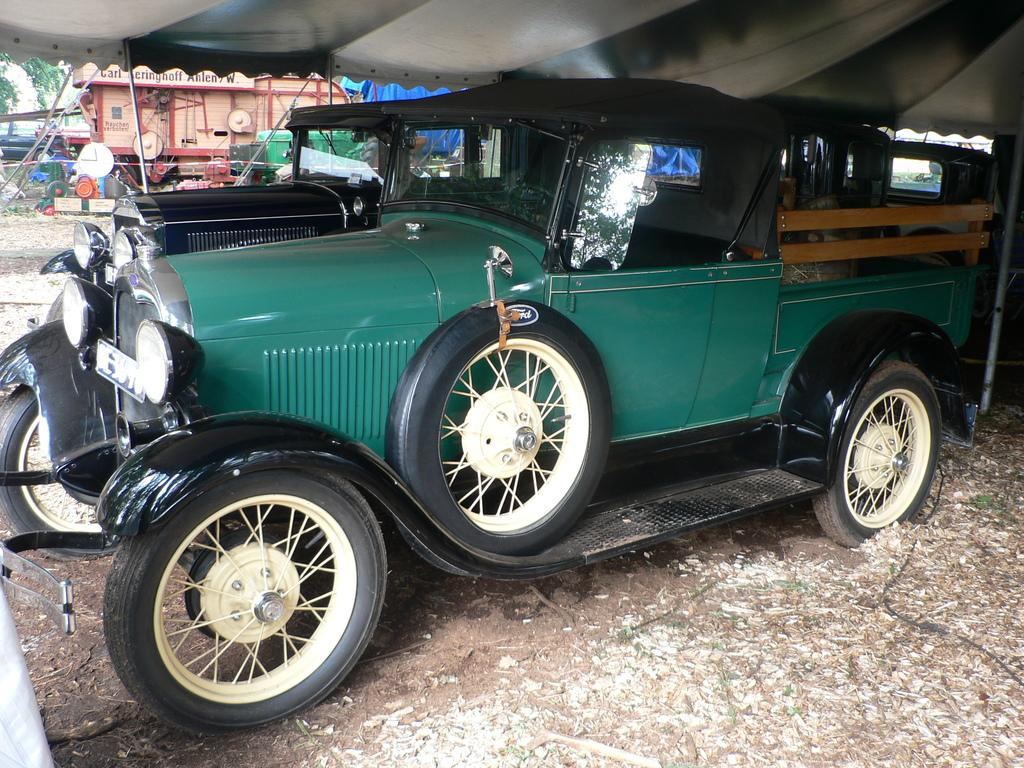What is the main subject of the image? There is an old vintage car in the middle of the image. What is covering the car? There is a tent above the car. What can be seen in the background of the image? There is a building in the background of the image. What is in front of the building? There are clocks in front of the building. What type of powder is being used for teaching in the image? There is no indication of any powder or teaching activity in the image. 